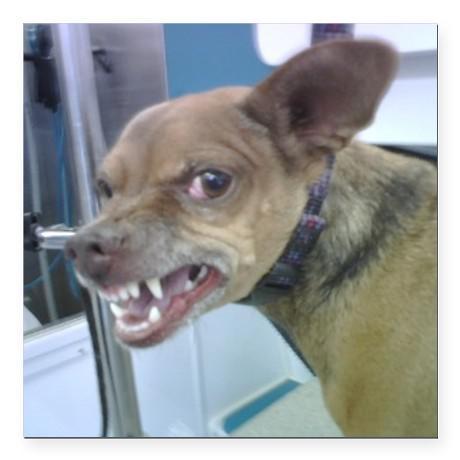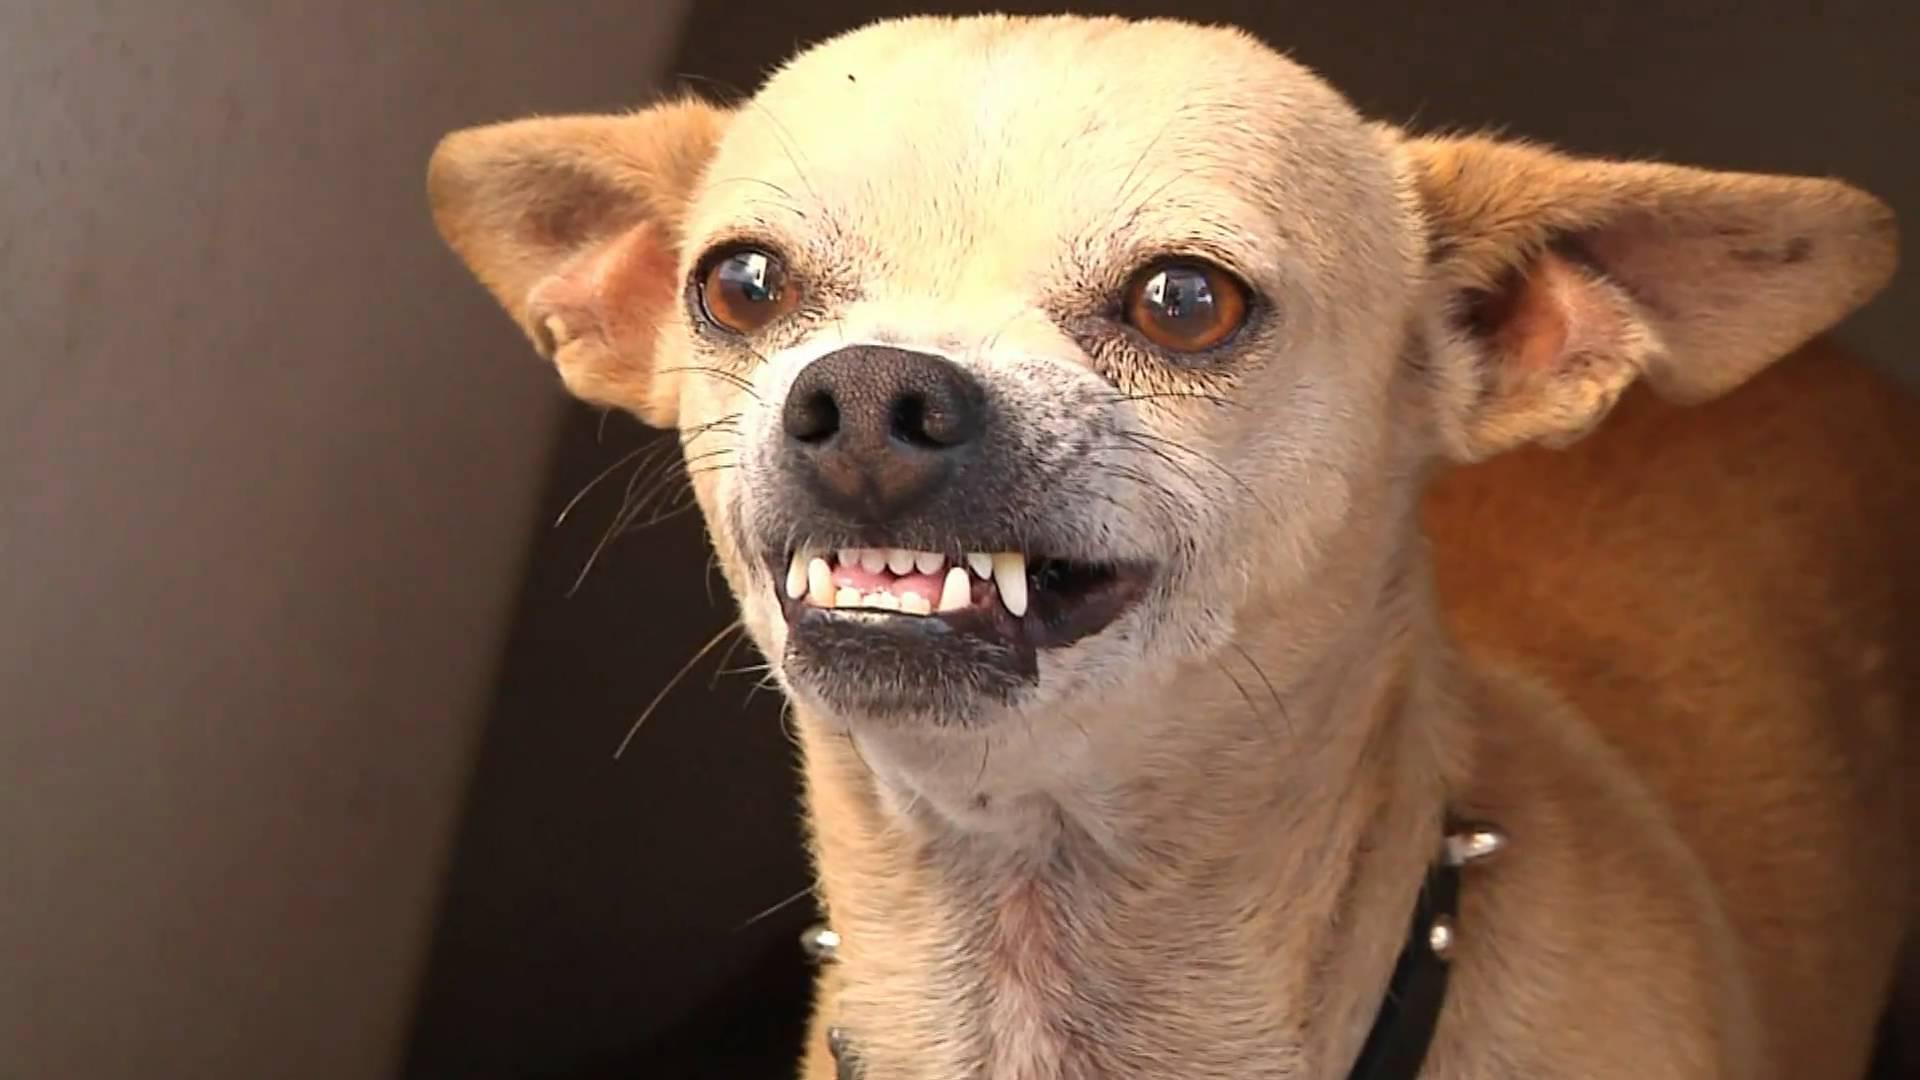The first image is the image on the left, the second image is the image on the right. Given the left and right images, does the statement "In at least one image, the dog's teeth are not bared." hold true? Answer yes or no. No. 